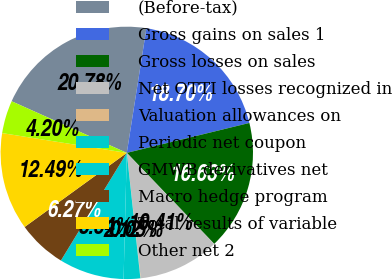Convert chart. <chart><loc_0><loc_0><loc_500><loc_500><pie_chart><fcel>(Before-tax)<fcel>Gross gains on sales 1<fcel>Gross losses on sales<fcel>Net OTTI losses recognized in<fcel>Valuation allowances on<fcel>Periodic net coupon<fcel>GMWB derivatives net<fcel>Macro hedge program<fcel>Total results of variable<fcel>Other net 2<nl><fcel>20.78%<fcel>18.7%<fcel>16.63%<fcel>10.41%<fcel>0.05%<fcel>2.12%<fcel>8.34%<fcel>6.27%<fcel>12.49%<fcel>4.2%<nl></chart> 